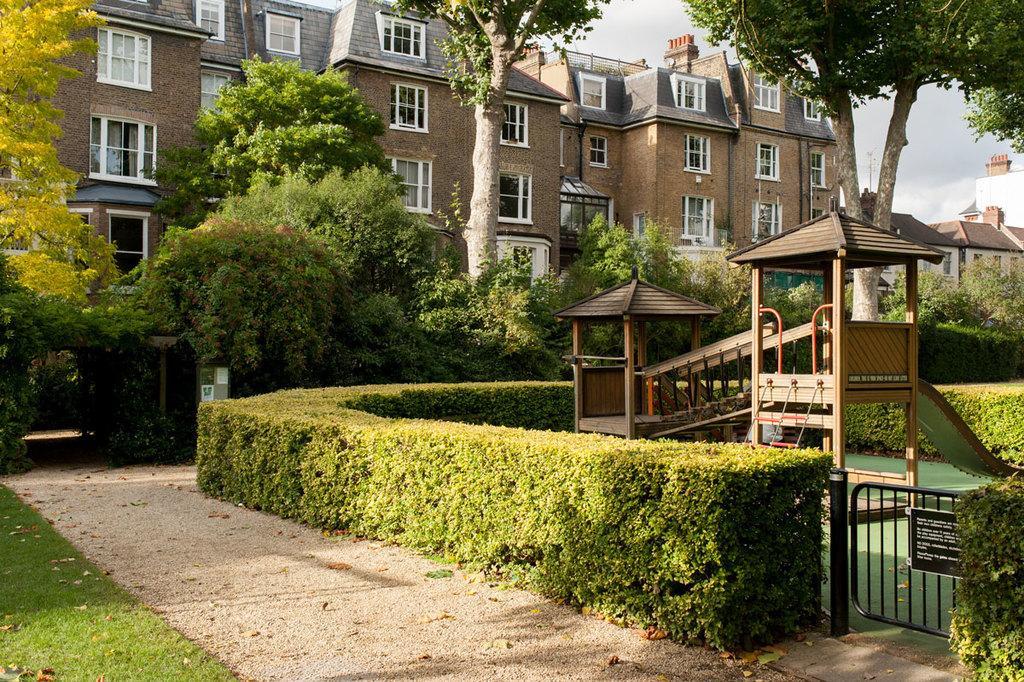Please provide a concise description of this image. In this picture we can see grass and plants on the ground, here we can see sheds, board and some objects and in the background we can see buildings, trees, sky. 